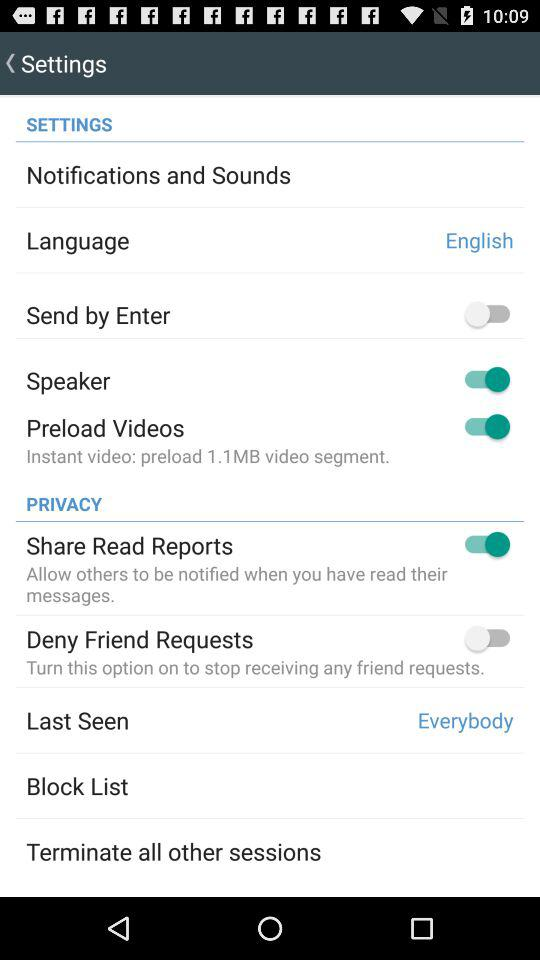How many items in the Privacy section have a switch?
Answer the question using a single word or phrase. 2 